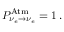Convert formula to latex. <formula><loc_0><loc_0><loc_500><loc_500>P _ { \nu _ { e } \to \nu _ { e } } ^ { A t m } = 1 \, .</formula> 